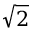<formula> <loc_0><loc_0><loc_500><loc_500>\sqrt { 2 }</formula> 